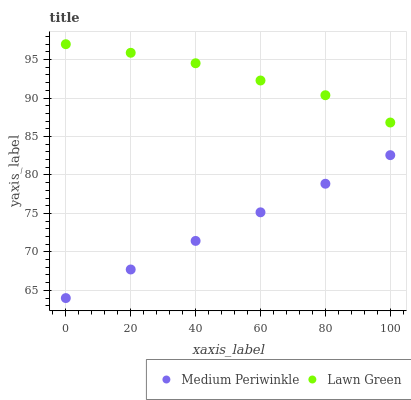Does Medium Periwinkle have the minimum area under the curve?
Answer yes or no. Yes. Does Lawn Green have the maximum area under the curve?
Answer yes or no. Yes. Does Medium Periwinkle have the maximum area under the curve?
Answer yes or no. No. Is Medium Periwinkle the smoothest?
Answer yes or no. Yes. Is Lawn Green the roughest?
Answer yes or no. Yes. Is Medium Periwinkle the roughest?
Answer yes or no. No. Does Medium Periwinkle have the lowest value?
Answer yes or no. Yes. Does Lawn Green have the highest value?
Answer yes or no. Yes. Does Medium Periwinkle have the highest value?
Answer yes or no. No. Is Medium Periwinkle less than Lawn Green?
Answer yes or no. Yes. Is Lawn Green greater than Medium Periwinkle?
Answer yes or no. Yes. Does Medium Periwinkle intersect Lawn Green?
Answer yes or no. No. 